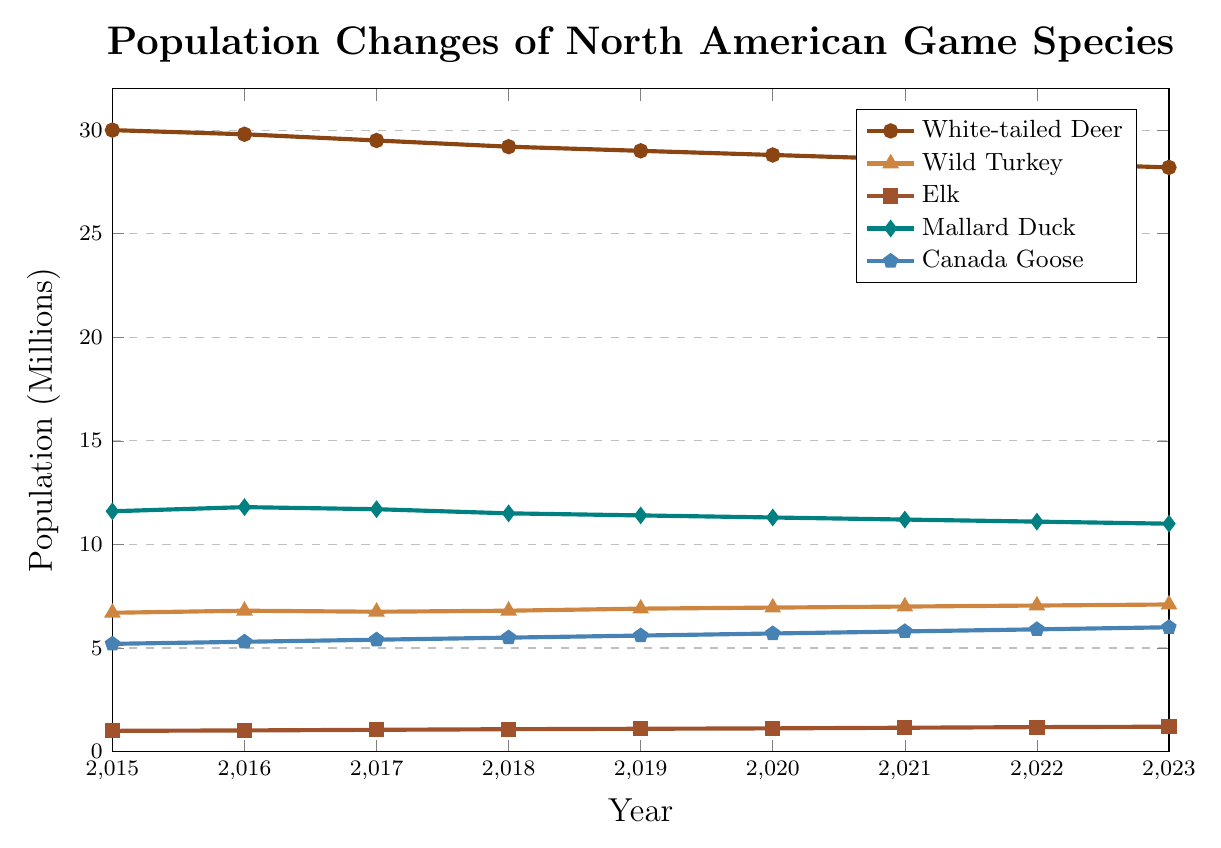What species showed the greatest increase in population from 2015 to 2023? To determine which species showed the greatest increase, we need to compare the initial and final population values for each species. White-tailed Deer decreased from 30 million to 28.2 million, Wild Turkey increased from 6.7 million to 7.1 million, Elk increased from 1 million to 1.2 million, Mallard Duck decreased from 11.6 million to 11 million, and Canada Goose increased from 5.2 million to 6 million. Elk shows the highest increase, from 1 million to 1.2 million (an increase of 0.2 million).
Answer: Elk During which year did the population of Wild Turkey exceed 7 million? Look at the line representing Wild Turkey. In 2021, the population reached 7 million and continued to rise in the subsequent years.
Answer: 2021 What is the average population size of Mallard Duck between 2015 and 2023? We calculate the average by summing up the population values of Mallard Duck from each year and dividing by the number of years: (11.6 + 11.8 + 11.7 + 11.5 + 11.4 + 11.3 + 11.2 + 11.1 + 11) / 9. The sum is 102.6, so the average is 102.6 / 9.
Answer: 11.4 million Which species had a consistent increase in population every year from 2015 to 2023? To determine this, look for species with a steady upward trend. Wild Turkey, Elk, and Canada Goose all show consistent annual increases.
Answer: Wild Turkey, Elk, Canada Goose How does the population of Canada Goose in 2023 compare to its population in 2015? Subtract the 2015 population from the 2023 population for Canada Goose. 6 million (2023) - 5.2 million (2015) = 0.8 million. Thus, the population has increased by 0.8 million.
Answer: Increased by 0.8 million Which species experienced a decline in population from 2015 to 2023, and by how much did their populations decrease? Subtract the 2023 values from the 2015 values for species with decreasing trends. White-tailed Deer decreased from 30 million to 28.2 million (1.8 million decrease), Mallard Duck from 11.6 million to 11 million (0.6 million decrease).
Answer: White-tailed Deer (1.8 million), Mallard Duck (0.6 million) What was the total population of all species combined in 2020? Sum the 2020 population values of all species: 28.8 million (White-tailed Deer) + 6.95 million (Wild Turkey) + 1.12 million (Elk) + 11.3 million (Mallard Duck) + 5.7 million (Canada Goose). The sum is 53.87 million.
Answer: 53.87 million Which species had the highest population in any given year, and what was that population? Look for the highest single data point across all species. The highest value is for White-tailed Deer in 2015, with a population of 30 million.
Answer: White-tailed Deer, 30 million 